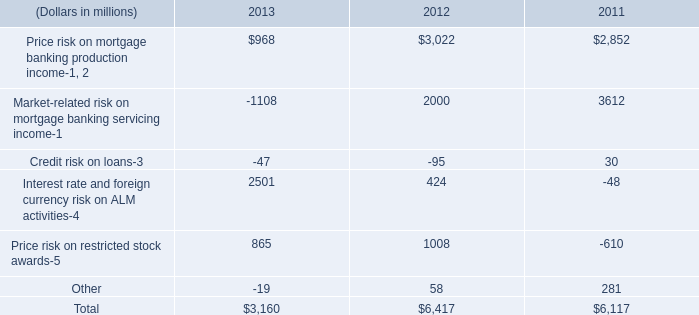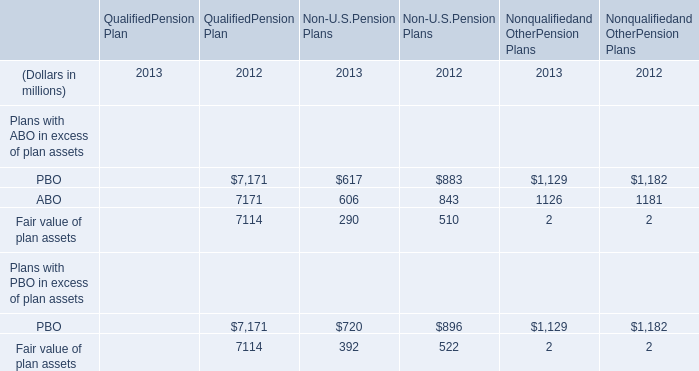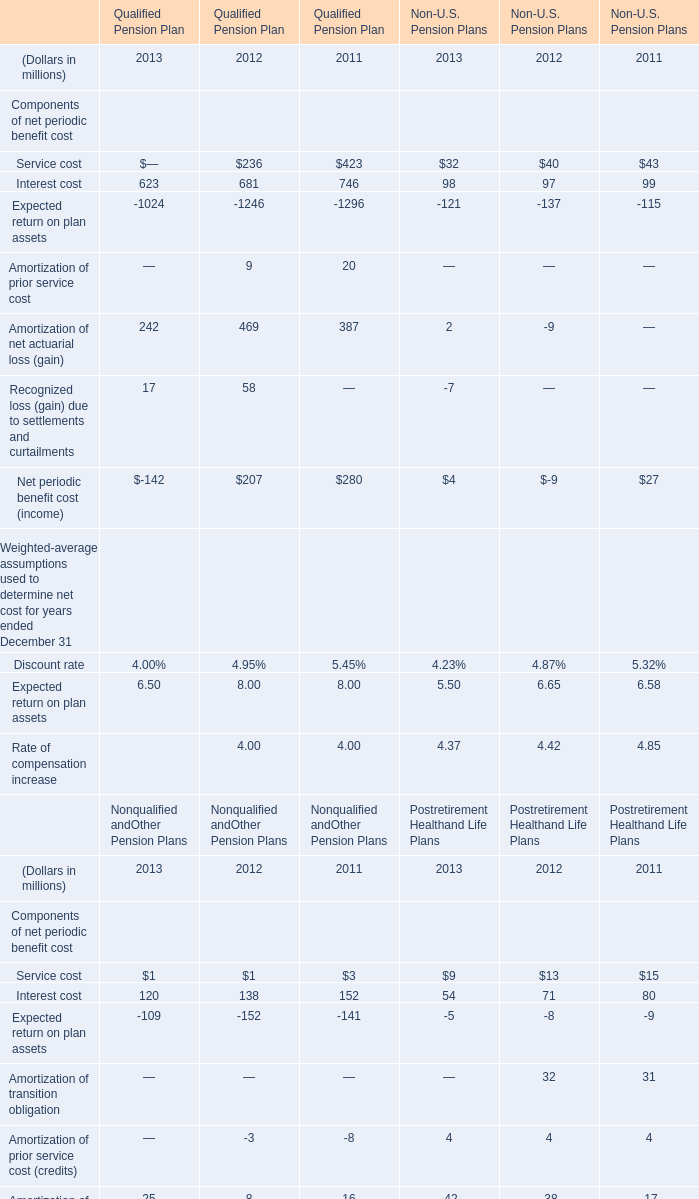What's the growth rate of ABO of Non-U.S.Pension Plans in 2013? 
Computations: ((606 - 843) / 843)
Answer: -0.28114. 